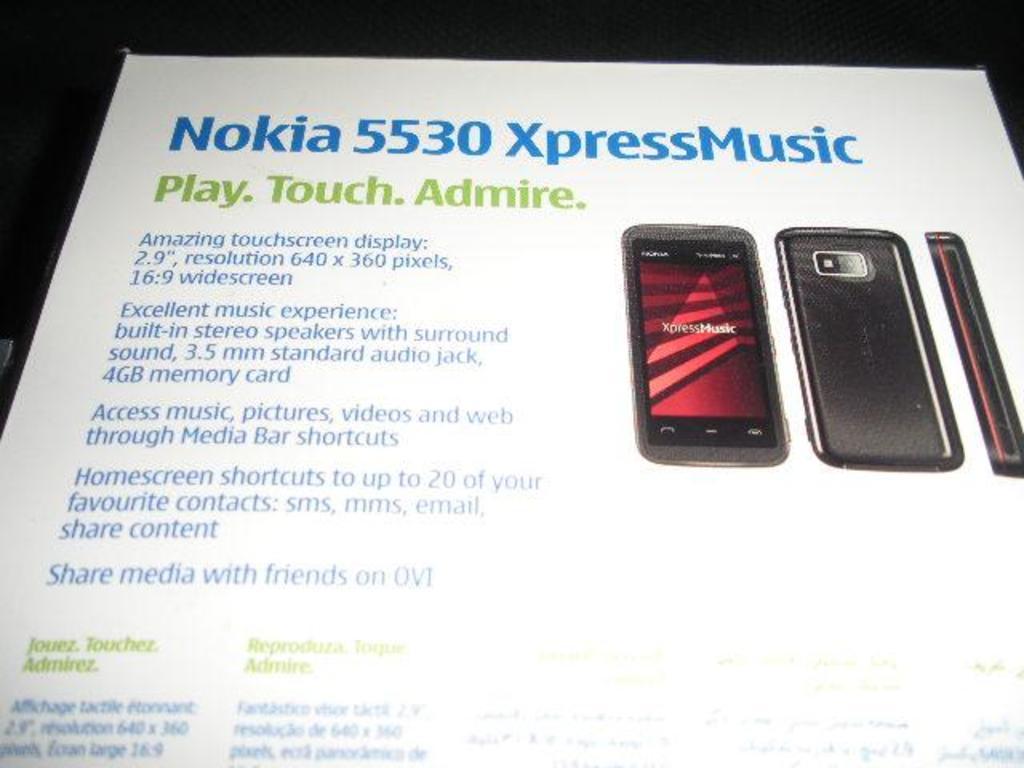What is the brand of phone?
Make the answer very short. Nokia. 